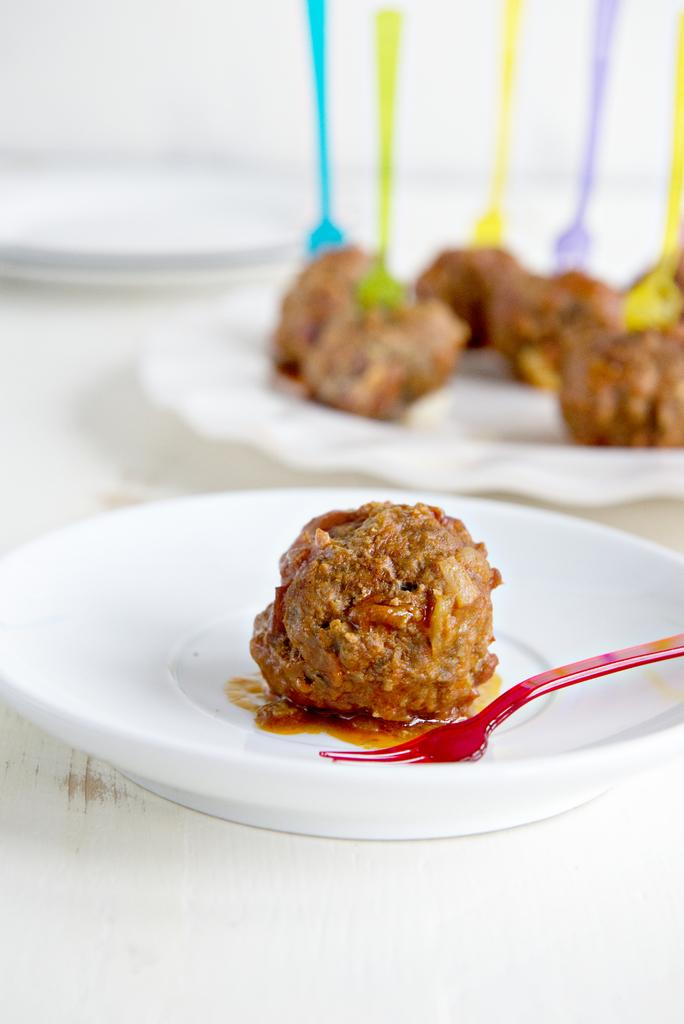What type of food items can be seen on plates in the image? There are baked food items on plates in the image. What utensils are present in the image? There are forks visible in the image. What type of heart can be seen in the image? There is no heart present in the image; it features baked food items on plates and forks. 